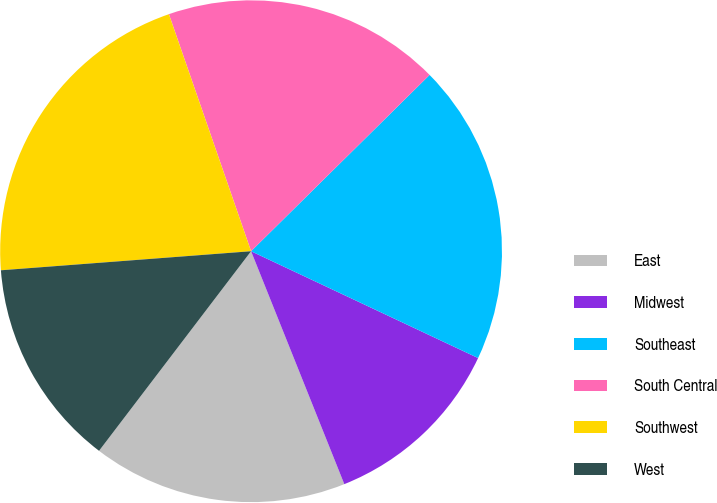<chart> <loc_0><loc_0><loc_500><loc_500><pie_chart><fcel>East<fcel>Midwest<fcel>Southeast<fcel>South Central<fcel>Southwest<fcel>West<nl><fcel>16.42%<fcel>11.94%<fcel>19.4%<fcel>17.91%<fcel>20.9%<fcel>13.43%<nl></chart> 